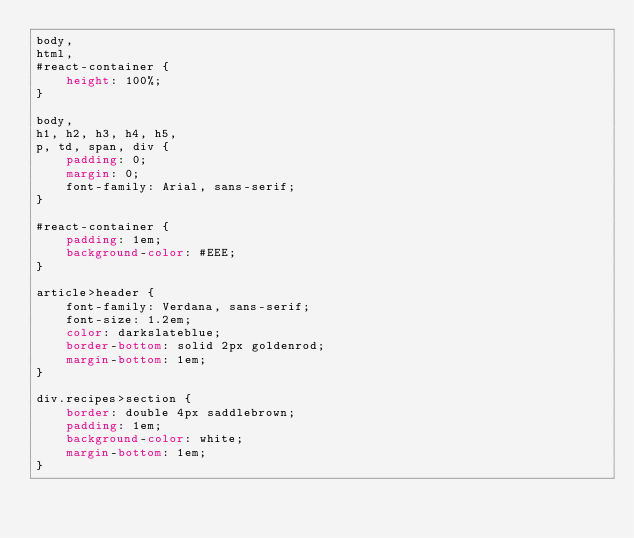Convert code to text. <code><loc_0><loc_0><loc_500><loc_500><_CSS_>body,
html,
#react-container {
    height: 100%;
}

body,
h1, h2, h3, h4, h5,
p, td, span, div {
    padding: 0;
    margin: 0;
    font-family: Arial, sans-serif;
}

#react-container {
    padding: 1em;
    background-color: #EEE;
}

article>header {
    font-family: Verdana, sans-serif;
    font-size: 1.2em;
    color: darkslateblue;
    border-bottom: solid 2px goldenrod;
    margin-bottom: 1em;
}

div.recipes>section {
    border: double 4px saddlebrown;
    padding: 1em;
    background-color: white;
    margin-bottom: 1em;
}
</code> 